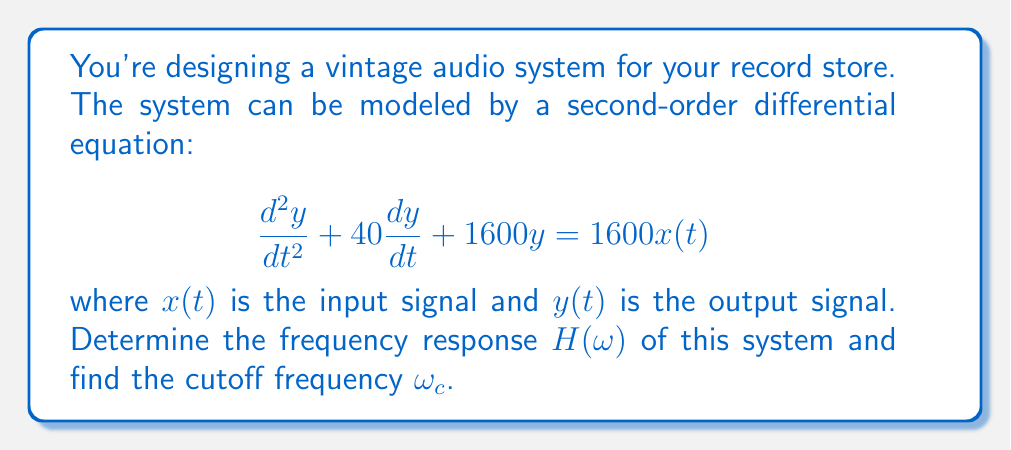What is the answer to this math problem? To solve this problem, we'll follow these steps:

1) The general form of a second-order differential equation is:

   $$\frac{d^2y}{dt^2} + 2\zeta\omega_n\frac{dy}{dt} + \omega_n^2y = \omega_n^2x(t)$$

   where $\zeta$ is the damping ratio and $\omega_n$ is the natural frequency.

2) Comparing our equation to the general form, we can identify:

   $2\zeta\omega_n = 40$
   $\omega_n^2 = 1600$

3) From $\omega_n^2 = 1600$, we get $\omega_n = 40$ rad/s.

4) The frequency response $H(\omega)$ for a second-order system is given by:

   $$H(\omega) = \frac{1}{1 - (\frac{\omega}{\omega_n})^2 + 2\zeta j(\frac{\omega}{\omega_n})}$$

5) Substituting $\omega_n = 40$ and $2\zeta\omega_n = 40$, we get $\zeta = 0.5$.

6) Therefore, our frequency response is:

   $$H(\omega) = \frac{1}{1 - (\frac{\omega}{40})^2 + j(\frac{\omega}{40})}$$

7) The cutoff frequency $\omega_c$ for a second-order system with $\zeta < \frac{1}{\sqrt{2}}$ is given by:

   $$\omega_c = \omega_n\sqrt{1 - 2\zeta^2}$$

8) Substituting our values:

   $$\omega_c = 40\sqrt{1 - 2(0.5)^2} = 40\sqrt{0.5} \approx 28.28$$ rad/s
Answer: The frequency response of the system is:

$$H(\omega) = \frac{1}{1 - (\frac{\omega}{40})^2 + j(\frac{\omega}{40})}$$

The cutoff frequency is approximately 28.28 rad/s. 